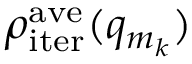Convert formula to latex. <formula><loc_0><loc_0><loc_500><loc_500>\rho _ { i t e r } ^ { a v e } ( q _ { m _ { k } } )</formula> 